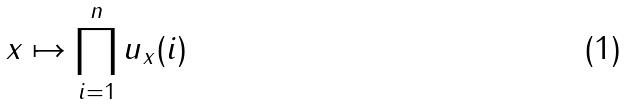<formula> <loc_0><loc_0><loc_500><loc_500>x \mapsto \prod _ { i = 1 } ^ { n } u _ { x } ( i )</formula> 